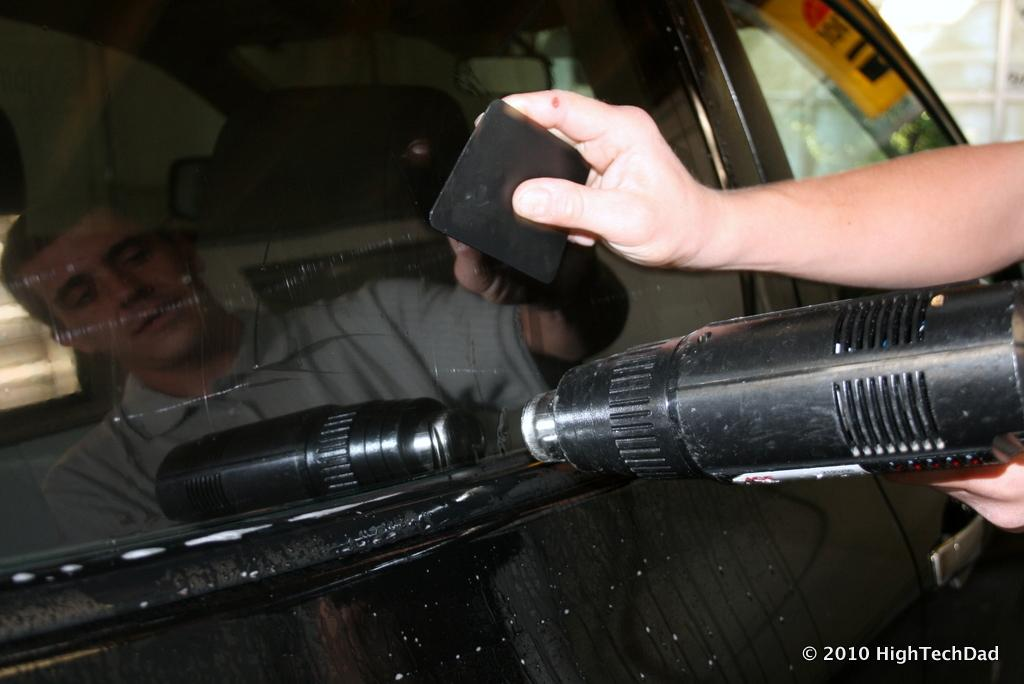What is being held by the hands in the image? The facts do not specify what objects are being held by the hands. Can you describe the reflection in the image? There is a reflection of a person on the glass of a vehicle in the image. Where can the snails be found in the image? There are no snails present in the image. What type of pot is being used by the person in the image? The facts do not mention a pot or any pot-related activity in the image. 